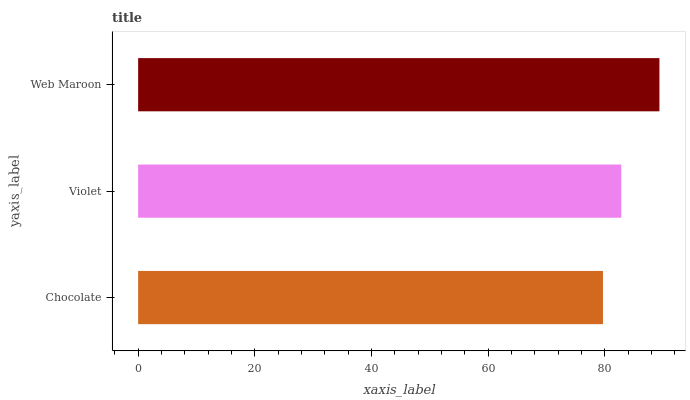Is Chocolate the minimum?
Answer yes or no. Yes. Is Web Maroon the maximum?
Answer yes or no. Yes. Is Violet the minimum?
Answer yes or no. No. Is Violet the maximum?
Answer yes or no. No. Is Violet greater than Chocolate?
Answer yes or no. Yes. Is Chocolate less than Violet?
Answer yes or no. Yes. Is Chocolate greater than Violet?
Answer yes or no. No. Is Violet less than Chocolate?
Answer yes or no. No. Is Violet the high median?
Answer yes or no. Yes. Is Violet the low median?
Answer yes or no. Yes. Is Web Maroon the high median?
Answer yes or no. No. Is Web Maroon the low median?
Answer yes or no. No. 